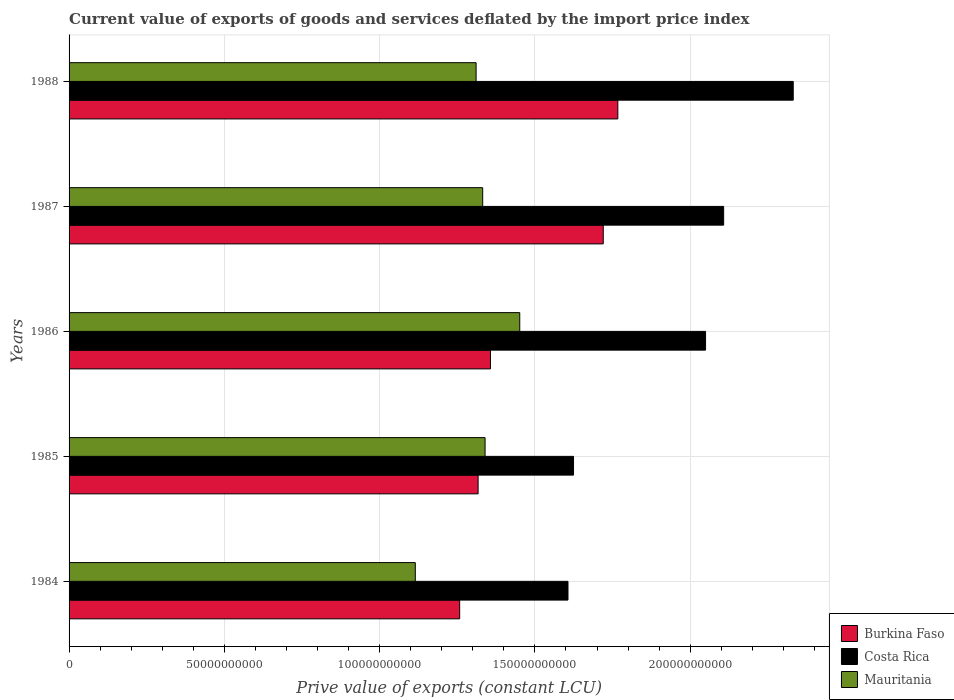How many groups of bars are there?
Make the answer very short. 5. How many bars are there on the 2nd tick from the bottom?
Offer a terse response. 3. In how many cases, is the number of bars for a given year not equal to the number of legend labels?
Ensure brevity in your answer.  0. What is the prive value of exports in Mauritania in 1988?
Your response must be concise. 1.31e+11. Across all years, what is the maximum prive value of exports in Costa Rica?
Your answer should be very brief. 2.33e+11. Across all years, what is the minimum prive value of exports in Costa Rica?
Provide a short and direct response. 1.61e+11. In which year was the prive value of exports in Mauritania maximum?
Provide a short and direct response. 1986. What is the total prive value of exports in Costa Rica in the graph?
Make the answer very short. 9.72e+11. What is the difference between the prive value of exports in Costa Rica in 1984 and that in 1987?
Your response must be concise. -5.01e+1. What is the difference between the prive value of exports in Burkina Faso in 1987 and the prive value of exports in Costa Rica in 1984?
Provide a short and direct response. 1.14e+1. What is the average prive value of exports in Burkina Faso per year?
Your answer should be very brief. 1.48e+11. In the year 1985, what is the difference between the prive value of exports in Mauritania and prive value of exports in Costa Rica?
Your response must be concise. -2.85e+1. What is the ratio of the prive value of exports in Mauritania in 1984 to that in 1985?
Your answer should be very brief. 0.83. Is the prive value of exports in Mauritania in 1986 less than that in 1988?
Your response must be concise. No. What is the difference between the highest and the second highest prive value of exports in Burkina Faso?
Your answer should be very brief. 4.70e+09. What is the difference between the highest and the lowest prive value of exports in Burkina Faso?
Keep it short and to the point. 5.09e+1. In how many years, is the prive value of exports in Mauritania greater than the average prive value of exports in Mauritania taken over all years?
Offer a terse response. 4. What does the 3rd bar from the top in 1986 represents?
Provide a succinct answer. Burkina Faso. What does the 2nd bar from the bottom in 1985 represents?
Your answer should be very brief. Costa Rica. Is it the case that in every year, the sum of the prive value of exports in Costa Rica and prive value of exports in Mauritania is greater than the prive value of exports in Burkina Faso?
Provide a short and direct response. Yes. How many bars are there?
Provide a short and direct response. 15. Does the graph contain any zero values?
Your response must be concise. No. Does the graph contain grids?
Ensure brevity in your answer.  Yes. How many legend labels are there?
Your answer should be very brief. 3. How are the legend labels stacked?
Ensure brevity in your answer.  Vertical. What is the title of the graph?
Offer a very short reply. Current value of exports of goods and services deflated by the import price index. What is the label or title of the X-axis?
Your answer should be compact. Prive value of exports (constant LCU). What is the Prive value of exports (constant LCU) of Burkina Faso in 1984?
Your answer should be very brief. 1.26e+11. What is the Prive value of exports (constant LCU) in Costa Rica in 1984?
Your answer should be compact. 1.61e+11. What is the Prive value of exports (constant LCU) in Mauritania in 1984?
Your response must be concise. 1.11e+11. What is the Prive value of exports (constant LCU) of Burkina Faso in 1985?
Your answer should be compact. 1.32e+11. What is the Prive value of exports (constant LCU) in Costa Rica in 1985?
Give a very brief answer. 1.62e+11. What is the Prive value of exports (constant LCU) of Mauritania in 1985?
Offer a terse response. 1.34e+11. What is the Prive value of exports (constant LCU) of Burkina Faso in 1986?
Offer a terse response. 1.36e+11. What is the Prive value of exports (constant LCU) in Costa Rica in 1986?
Your answer should be compact. 2.05e+11. What is the Prive value of exports (constant LCU) of Mauritania in 1986?
Keep it short and to the point. 1.45e+11. What is the Prive value of exports (constant LCU) of Burkina Faso in 1987?
Provide a succinct answer. 1.72e+11. What is the Prive value of exports (constant LCU) of Costa Rica in 1987?
Offer a very short reply. 2.11e+11. What is the Prive value of exports (constant LCU) in Mauritania in 1987?
Offer a terse response. 1.33e+11. What is the Prive value of exports (constant LCU) of Burkina Faso in 1988?
Keep it short and to the point. 1.77e+11. What is the Prive value of exports (constant LCU) in Costa Rica in 1988?
Ensure brevity in your answer.  2.33e+11. What is the Prive value of exports (constant LCU) of Mauritania in 1988?
Keep it short and to the point. 1.31e+11. Across all years, what is the maximum Prive value of exports (constant LCU) of Burkina Faso?
Your response must be concise. 1.77e+11. Across all years, what is the maximum Prive value of exports (constant LCU) of Costa Rica?
Offer a terse response. 2.33e+11. Across all years, what is the maximum Prive value of exports (constant LCU) in Mauritania?
Your response must be concise. 1.45e+11. Across all years, what is the minimum Prive value of exports (constant LCU) in Burkina Faso?
Offer a terse response. 1.26e+11. Across all years, what is the minimum Prive value of exports (constant LCU) of Costa Rica?
Your answer should be very brief. 1.61e+11. Across all years, what is the minimum Prive value of exports (constant LCU) of Mauritania?
Ensure brevity in your answer.  1.11e+11. What is the total Prive value of exports (constant LCU) of Burkina Faso in the graph?
Offer a very short reply. 7.42e+11. What is the total Prive value of exports (constant LCU) in Costa Rica in the graph?
Your response must be concise. 9.72e+11. What is the total Prive value of exports (constant LCU) in Mauritania in the graph?
Offer a very short reply. 6.55e+11. What is the difference between the Prive value of exports (constant LCU) of Burkina Faso in 1984 and that in 1985?
Offer a very short reply. -5.94e+09. What is the difference between the Prive value of exports (constant LCU) of Costa Rica in 1984 and that in 1985?
Offer a terse response. -1.78e+09. What is the difference between the Prive value of exports (constant LCU) in Mauritania in 1984 and that in 1985?
Ensure brevity in your answer.  -2.25e+1. What is the difference between the Prive value of exports (constant LCU) in Burkina Faso in 1984 and that in 1986?
Keep it short and to the point. -9.92e+09. What is the difference between the Prive value of exports (constant LCU) of Costa Rica in 1984 and that in 1986?
Offer a very short reply. -4.43e+1. What is the difference between the Prive value of exports (constant LCU) of Mauritania in 1984 and that in 1986?
Offer a very short reply. -3.36e+1. What is the difference between the Prive value of exports (constant LCU) of Burkina Faso in 1984 and that in 1987?
Provide a succinct answer. -4.62e+1. What is the difference between the Prive value of exports (constant LCU) of Costa Rica in 1984 and that in 1987?
Your response must be concise. -5.01e+1. What is the difference between the Prive value of exports (constant LCU) of Mauritania in 1984 and that in 1987?
Make the answer very short. -2.17e+1. What is the difference between the Prive value of exports (constant LCU) of Burkina Faso in 1984 and that in 1988?
Your answer should be very brief. -5.09e+1. What is the difference between the Prive value of exports (constant LCU) of Costa Rica in 1984 and that in 1988?
Offer a very short reply. -7.25e+1. What is the difference between the Prive value of exports (constant LCU) of Mauritania in 1984 and that in 1988?
Provide a short and direct response. -1.96e+1. What is the difference between the Prive value of exports (constant LCU) in Burkina Faso in 1985 and that in 1986?
Give a very brief answer. -3.98e+09. What is the difference between the Prive value of exports (constant LCU) in Costa Rica in 1985 and that in 1986?
Ensure brevity in your answer.  -4.25e+1. What is the difference between the Prive value of exports (constant LCU) of Mauritania in 1985 and that in 1986?
Your response must be concise. -1.12e+1. What is the difference between the Prive value of exports (constant LCU) in Burkina Faso in 1985 and that in 1987?
Your answer should be compact. -4.03e+1. What is the difference between the Prive value of exports (constant LCU) in Costa Rica in 1985 and that in 1987?
Give a very brief answer. -4.83e+1. What is the difference between the Prive value of exports (constant LCU) in Mauritania in 1985 and that in 1987?
Give a very brief answer. 7.71e+08. What is the difference between the Prive value of exports (constant LCU) of Burkina Faso in 1985 and that in 1988?
Your answer should be very brief. -4.50e+1. What is the difference between the Prive value of exports (constant LCU) of Costa Rica in 1985 and that in 1988?
Your answer should be compact. -7.07e+1. What is the difference between the Prive value of exports (constant LCU) of Mauritania in 1985 and that in 1988?
Your response must be concise. 2.89e+09. What is the difference between the Prive value of exports (constant LCU) of Burkina Faso in 1986 and that in 1987?
Your answer should be compact. -3.63e+1. What is the difference between the Prive value of exports (constant LCU) of Costa Rica in 1986 and that in 1987?
Give a very brief answer. -5.82e+09. What is the difference between the Prive value of exports (constant LCU) in Mauritania in 1986 and that in 1987?
Keep it short and to the point. 1.19e+1. What is the difference between the Prive value of exports (constant LCU) of Burkina Faso in 1986 and that in 1988?
Your answer should be compact. -4.10e+1. What is the difference between the Prive value of exports (constant LCU) in Costa Rica in 1986 and that in 1988?
Offer a terse response. -2.82e+1. What is the difference between the Prive value of exports (constant LCU) of Mauritania in 1986 and that in 1988?
Keep it short and to the point. 1.41e+1. What is the difference between the Prive value of exports (constant LCU) in Burkina Faso in 1987 and that in 1988?
Your answer should be very brief. -4.70e+09. What is the difference between the Prive value of exports (constant LCU) in Costa Rica in 1987 and that in 1988?
Ensure brevity in your answer.  -2.24e+1. What is the difference between the Prive value of exports (constant LCU) of Mauritania in 1987 and that in 1988?
Your answer should be compact. 2.12e+09. What is the difference between the Prive value of exports (constant LCU) in Burkina Faso in 1984 and the Prive value of exports (constant LCU) in Costa Rica in 1985?
Offer a very short reply. -3.67e+1. What is the difference between the Prive value of exports (constant LCU) of Burkina Faso in 1984 and the Prive value of exports (constant LCU) of Mauritania in 1985?
Make the answer very short. -8.18e+09. What is the difference between the Prive value of exports (constant LCU) of Costa Rica in 1984 and the Prive value of exports (constant LCU) of Mauritania in 1985?
Give a very brief answer. 2.67e+1. What is the difference between the Prive value of exports (constant LCU) in Burkina Faso in 1984 and the Prive value of exports (constant LCU) in Costa Rica in 1986?
Give a very brief answer. -7.92e+1. What is the difference between the Prive value of exports (constant LCU) in Burkina Faso in 1984 and the Prive value of exports (constant LCU) in Mauritania in 1986?
Your answer should be very brief. -1.93e+1. What is the difference between the Prive value of exports (constant LCU) of Costa Rica in 1984 and the Prive value of exports (constant LCU) of Mauritania in 1986?
Ensure brevity in your answer.  1.55e+1. What is the difference between the Prive value of exports (constant LCU) in Burkina Faso in 1984 and the Prive value of exports (constant LCU) in Costa Rica in 1987?
Your answer should be compact. -8.50e+1. What is the difference between the Prive value of exports (constant LCU) in Burkina Faso in 1984 and the Prive value of exports (constant LCU) in Mauritania in 1987?
Your response must be concise. -7.41e+09. What is the difference between the Prive value of exports (constant LCU) in Costa Rica in 1984 and the Prive value of exports (constant LCU) in Mauritania in 1987?
Offer a very short reply. 2.75e+1. What is the difference between the Prive value of exports (constant LCU) of Burkina Faso in 1984 and the Prive value of exports (constant LCU) of Costa Rica in 1988?
Provide a succinct answer. -1.07e+11. What is the difference between the Prive value of exports (constant LCU) in Burkina Faso in 1984 and the Prive value of exports (constant LCU) in Mauritania in 1988?
Offer a terse response. -5.29e+09. What is the difference between the Prive value of exports (constant LCU) of Costa Rica in 1984 and the Prive value of exports (constant LCU) of Mauritania in 1988?
Provide a succinct answer. 2.96e+1. What is the difference between the Prive value of exports (constant LCU) of Burkina Faso in 1985 and the Prive value of exports (constant LCU) of Costa Rica in 1986?
Give a very brief answer. -7.32e+1. What is the difference between the Prive value of exports (constant LCU) of Burkina Faso in 1985 and the Prive value of exports (constant LCU) of Mauritania in 1986?
Offer a terse response. -1.34e+1. What is the difference between the Prive value of exports (constant LCU) of Costa Rica in 1985 and the Prive value of exports (constant LCU) of Mauritania in 1986?
Make the answer very short. 1.73e+1. What is the difference between the Prive value of exports (constant LCU) in Burkina Faso in 1985 and the Prive value of exports (constant LCU) in Costa Rica in 1987?
Your answer should be compact. -7.91e+1. What is the difference between the Prive value of exports (constant LCU) of Burkina Faso in 1985 and the Prive value of exports (constant LCU) of Mauritania in 1987?
Ensure brevity in your answer.  -1.48e+09. What is the difference between the Prive value of exports (constant LCU) in Costa Rica in 1985 and the Prive value of exports (constant LCU) in Mauritania in 1987?
Offer a very short reply. 2.92e+1. What is the difference between the Prive value of exports (constant LCU) in Burkina Faso in 1985 and the Prive value of exports (constant LCU) in Costa Rica in 1988?
Ensure brevity in your answer.  -1.01e+11. What is the difference between the Prive value of exports (constant LCU) in Burkina Faso in 1985 and the Prive value of exports (constant LCU) in Mauritania in 1988?
Your answer should be very brief. 6.44e+08. What is the difference between the Prive value of exports (constant LCU) in Costa Rica in 1985 and the Prive value of exports (constant LCU) in Mauritania in 1988?
Your answer should be compact. 3.14e+1. What is the difference between the Prive value of exports (constant LCU) in Burkina Faso in 1986 and the Prive value of exports (constant LCU) in Costa Rica in 1987?
Your answer should be very brief. -7.51e+1. What is the difference between the Prive value of exports (constant LCU) of Burkina Faso in 1986 and the Prive value of exports (constant LCU) of Mauritania in 1987?
Keep it short and to the point. 2.51e+09. What is the difference between the Prive value of exports (constant LCU) in Costa Rica in 1986 and the Prive value of exports (constant LCU) in Mauritania in 1987?
Make the answer very short. 7.18e+1. What is the difference between the Prive value of exports (constant LCU) in Burkina Faso in 1986 and the Prive value of exports (constant LCU) in Costa Rica in 1988?
Provide a short and direct response. -9.75e+1. What is the difference between the Prive value of exports (constant LCU) of Burkina Faso in 1986 and the Prive value of exports (constant LCU) of Mauritania in 1988?
Your answer should be compact. 4.63e+09. What is the difference between the Prive value of exports (constant LCU) in Costa Rica in 1986 and the Prive value of exports (constant LCU) in Mauritania in 1988?
Give a very brief answer. 7.39e+1. What is the difference between the Prive value of exports (constant LCU) of Burkina Faso in 1987 and the Prive value of exports (constant LCU) of Costa Rica in 1988?
Offer a terse response. -6.12e+1. What is the difference between the Prive value of exports (constant LCU) of Burkina Faso in 1987 and the Prive value of exports (constant LCU) of Mauritania in 1988?
Your answer should be very brief. 4.09e+1. What is the difference between the Prive value of exports (constant LCU) in Costa Rica in 1987 and the Prive value of exports (constant LCU) in Mauritania in 1988?
Your response must be concise. 7.97e+1. What is the average Prive value of exports (constant LCU) of Burkina Faso per year?
Your answer should be compact. 1.48e+11. What is the average Prive value of exports (constant LCU) of Costa Rica per year?
Offer a terse response. 1.94e+11. What is the average Prive value of exports (constant LCU) in Mauritania per year?
Keep it short and to the point. 1.31e+11. In the year 1984, what is the difference between the Prive value of exports (constant LCU) in Burkina Faso and Prive value of exports (constant LCU) in Costa Rica?
Make the answer very short. -3.49e+1. In the year 1984, what is the difference between the Prive value of exports (constant LCU) of Burkina Faso and Prive value of exports (constant LCU) of Mauritania?
Your answer should be compact. 1.43e+1. In the year 1984, what is the difference between the Prive value of exports (constant LCU) in Costa Rica and Prive value of exports (constant LCU) in Mauritania?
Provide a succinct answer. 4.92e+1. In the year 1985, what is the difference between the Prive value of exports (constant LCU) of Burkina Faso and Prive value of exports (constant LCU) of Costa Rica?
Provide a succinct answer. -3.07e+1. In the year 1985, what is the difference between the Prive value of exports (constant LCU) of Burkina Faso and Prive value of exports (constant LCU) of Mauritania?
Your answer should be compact. -2.25e+09. In the year 1985, what is the difference between the Prive value of exports (constant LCU) of Costa Rica and Prive value of exports (constant LCU) of Mauritania?
Make the answer very short. 2.85e+1. In the year 1986, what is the difference between the Prive value of exports (constant LCU) of Burkina Faso and Prive value of exports (constant LCU) of Costa Rica?
Your answer should be compact. -6.93e+1. In the year 1986, what is the difference between the Prive value of exports (constant LCU) in Burkina Faso and Prive value of exports (constant LCU) in Mauritania?
Your response must be concise. -9.43e+09. In the year 1986, what is the difference between the Prive value of exports (constant LCU) in Costa Rica and Prive value of exports (constant LCU) in Mauritania?
Ensure brevity in your answer.  5.98e+1. In the year 1987, what is the difference between the Prive value of exports (constant LCU) in Burkina Faso and Prive value of exports (constant LCU) in Costa Rica?
Your answer should be very brief. -3.88e+1. In the year 1987, what is the difference between the Prive value of exports (constant LCU) in Burkina Faso and Prive value of exports (constant LCU) in Mauritania?
Your answer should be compact. 3.88e+1. In the year 1987, what is the difference between the Prive value of exports (constant LCU) of Costa Rica and Prive value of exports (constant LCU) of Mauritania?
Make the answer very short. 7.76e+1. In the year 1988, what is the difference between the Prive value of exports (constant LCU) in Burkina Faso and Prive value of exports (constant LCU) in Costa Rica?
Provide a succinct answer. -5.65e+1. In the year 1988, what is the difference between the Prive value of exports (constant LCU) of Burkina Faso and Prive value of exports (constant LCU) of Mauritania?
Provide a succinct answer. 4.56e+1. In the year 1988, what is the difference between the Prive value of exports (constant LCU) of Costa Rica and Prive value of exports (constant LCU) of Mauritania?
Provide a succinct answer. 1.02e+11. What is the ratio of the Prive value of exports (constant LCU) of Burkina Faso in 1984 to that in 1985?
Offer a terse response. 0.95. What is the ratio of the Prive value of exports (constant LCU) of Mauritania in 1984 to that in 1985?
Give a very brief answer. 0.83. What is the ratio of the Prive value of exports (constant LCU) in Burkina Faso in 1984 to that in 1986?
Your response must be concise. 0.93. What is the ratio of the Prive value of exports (constant LCU) of Costa Rica in 1984 to that in 1986?
Offer a terse response. 0.78. What is the ratio of the Prive value of exports (constant LCU) of Mauritania in 1984 to that in 1986?
Provide a succinct answer. 0.77. What is the ratio of the Prive value of exports (constant LCU) in Burkina Faso in 1984 to that in 1987?
Keep it short and to the point. 0.73. What is the ratio of the Prive value of exports (constant LCU) of Costa Rica in 1984 to that in 1987?
Keep it short and to the point. 0.76. What is the ratio of the Prive value of exports (constant LCU) of Mauritania in 1984 to that in 1987?
Offer a terse response. 0.84. What is the ratio of the Prive value of exports (constant LCU) of Burkina Faso in 1984 to that in 1988?
Give a very brief answer. 0.71. What is the ratio of the Prive value of exports (constant LCU) in Costa Rica in 1984 to that in 1988?
Offer a terse response. 0.69. What is the ratio of the Prive value of exports (constant LCU) in Mauritania in 1984 to that in 1988?
Keep it short and to the point. 0.85. What is the ratio of the Prive value of exports (constant LCU) of Burkina Faso in 1985 to that in 1986?
Your response must be concise. 0.97. What is the ratio of the Prive value of exports (constant LCU) of Costa Rica in 1985 to that in 1986?
Offer a terse response. 0.79. What is the ratio of the Prive value of exports (constant LCU) in Burkina Faso in 1985 to that in 1987?
Keep it short and to the point. 0.77. What is the ratio of the Prive value of exports (constant LCU) of Costa Rica in 1985 to that in 1987?
Ensure brevity in your answer.  0.77. What is the ratio of the Prive value of exports (constant LCU) of Burkina Faso in 1985 to that in 1988?
Your answer should be compact. 0.75. What is the ratio of the Prive value of exports (constant LCU) in Costa Rica in 1985 to that in 1988?
Your answer should be very brief. 0.7. What is the ratio of the Prive value of exports (constant LCU) in Mauritania in 1985 to that in 1988?
Give a very brief answer. 1.02. What is the ratio of the Prive value of exports (constant LCU) in Burkina Faso in 1986 to that in 1987?
Keep it short and to the point. 0.79. What is the ratio of the Prive value of exports (constant LCU) of Costa Rica in 1986 to that in 1987?
Your response must be concise. 0.97. What is the ratio of the Prive value of exports (constant LCU) of Mauritania in 1986 to that in 1987?
Make the answer very short. 1.09. What is the ratio of the Prive value of exports (constant LCU) of Burkina Faso in 1986 to that in 1988?
Your answer should be compact. 0.77. What is the ratio of the Prive value of exports (constant LCU) in Costa Rica in 1986 to that in 1988?
Offer a very short reply. 0.88. What is the ratio of the Prive value of exports (constant LCU) in Mauritania in 1986 to that in 1988?
Offer a terse response. 1.11. What is the ratio of the Prive value of exports (constant LCU) of Burkina Faso in 1987 to that in 1988?
Ensure brevity in your answer.  0.97. What is the ratio of the Prive value of exports (constant LCU) of Costa Rica in 1987 to that in 1988?
Your response must be concise. 0.9. What is the ratio of the Prive value of exports (constant LCU) of Mauritania in 1987 to that in 1988?
Make the answer very short. 1.02. What is the difference between the highest and the second highest Prive value of exports (constant LCU) in Burkina Faso?
Offer a very short reply. 4.70e+09. What is the difference between the highest and the second highest Prive value of exports (constant LCU) in Costa Rica?
Ensure brevity in your answer.  2.24e+1. What is the difference between the highest and the second highest Prive value of exports (constant LCU) in Mauritania?
Keep it short and to the point. 1.12e+1. What is the difference between the highest and the lowest Prive value of exports (constant LCU) of Burkina Faso?
Give a very brief answer. 5.09e+1. What is the difference between the highest and the lowest Prive value of exports (constant LCU) in Costa Rica?
Make the answer very short. 7.25e+1. What is the difference between the highest and the lowest Prive value of exports (constant LCU) in Mauritania?
Make the answer very short. 3.36e+1. 